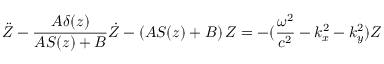Convert formula to latex. <formula><loc_0><loc_0><loc_500><loc_500>\ddot { Z } - \frac { A \delta ( z ) } { A S ( z ) + B } \dot { Z } - \left ( A S ( z ) + B \right ) Z = - ( \frac { \omega ^ { 2 } } { c ^ { 2 } } - k _ { x } ^ { 2 } - k _ { y } ^ { 2 } ) Z</formula> 